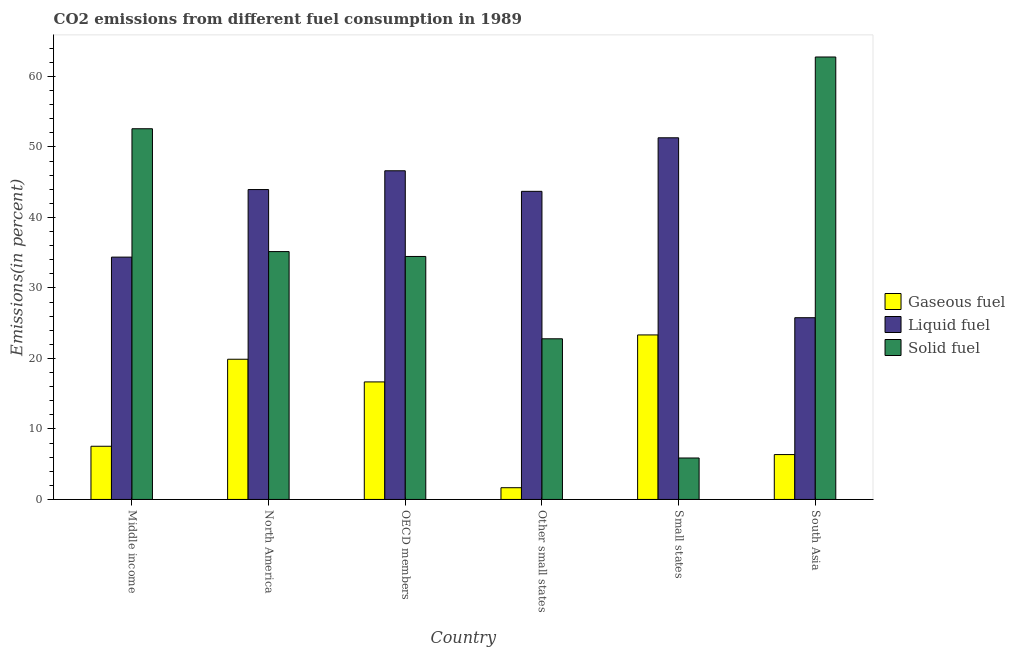How many groups of bars are there?
Your response must be concise. 6. How many bars are there on the 1st tick from the left?
Offer a very short reply. 3. How many bars are there on the 4th tick from the right?
Your answer should be compact. 3. What is the label of the 5th group of bars from the left?
Your answer should be very brief. Small states. What is the percentage of liquid fuel emission in Small states?
Your response must be concise. 51.3. Across all countries, what is the maximum percentage of gaseous fuel emission?
Make the answer very short. 23.34. Across all countries, what is the minimum percentage of liquid fuel emission?
Offer a terse response. 25.78. In which country was the percentage of liquid fuel emission maximum?
Provide a succinct answer. Small states. In which country was the percentage of gaseous fuel emission minimum?
Provide a succinct answer. Other small states. What is the total percentage of liquid fuel emission in the graph?
Keep it short and to the point. 245.73. What is the difference between the percentage of solid fuel emission in OECD members and that in Small states?
Make the answer very short. 28.59. What is the difference between the percentage of solid fuel emission in OECD members and the percentage of gaseous fuel emission in Middle income?
Give a very brief answer. 26.92. What is the average percentage of gaseous fuel emission per country?
Provide a succinct answer. 12.58. What is the difference between the percentage of liquid fuel emission and percentage of gaseous fuel emission in Other small states?
Provide a short and direct response. 42.04. What is the ratio of the percentage of solid fuel emission in OECD members to that in Other small states?
Give a very brief answer. 1.51. Is the difference between the percentage of liquid fuel emission in North America and Other small states greater than the difference between the percentage of solid fuel emission in North America and Other small states?
Give a very brief answer. No. What is the difference between the highest and the second highest percentage of solid fuel emission?
Ensure brevity in your answer.  10.18. What is the difference between the highest and the lowest percentage of solid fuel emission?
Ensure brevity in your answer.  56.88. In how many countries, is the percentage of solid fuel emission greater than the average percentage of solid fuel emission taken over all countries?
Give a very brief answer. 2. What does the 3rd bar from the left in Small states represents?
Ensure brevity in your answer.  Solid fuel. What does the 3rd bar from the right in North America represents?
Your response must be concise. Gaseous fuel. Is it the case that in every country, the sum of the percentage of gaseous fuel emission and percentage of liquid fuel emission is greater than the percentage of solid fuel emission?
Keep it short and to the point. No. How many bars are there?
Offer a very short reply. 18. Are all the bars in the graph horizontal?
Keep it short and to the point. No. Does the graph contain grids?
Keep it short and to the point. No. How are the legend labels stacked?
Make the answer very short. Vertical. What is the title of the graph?
Give a very brief answer. CO2 emissions from different fuel consumption in 1989. Does "Resident buildings and public services" appear as one of the legend labels in the graph?
Offer a terse response. No. What is the label or title of the Y-axis?
Your response must be concise. Emissions(in percent). What is the Emissions(in percent) in Gaseous fuel in Middle income?
Give a very brief answer. 7.55. What is the Emissions(in percent) of Liquid fuel in Middle income?
Offer a very short reply. 34.37. What is the Emissions(in percent) in Solid fuel in Middle income?
Provide a succinct answer. 52.58. What is the Emissions(in percent) of Gaseous fuel in North America?
Your answer should be very brief. 19.89. What is the Emissions(in percent) in Liquid fuel in North America?
Keep it short and to the point. 43.96. What is the Emissions(in percent) in Solid fuel in North America?
Make the answer very short. 35.16. What is the Emissions(in percent) of Gaseous fuel in OECD members?
Offer a terse response. 16.67. What is the Emissions(in percent) of Liquid fuel in OECD members?
Keep it short and to the point. 46.62. What is the Emissions(in percent) in Solid fuel in OECD members?
Ensure brevity in your answer.  34.47. What is the Emissions(in percent) in Gaseous fuel in Other small states?
Ensure brevity in your answer.  1.66. What is the Emissions(in percent) of Liquid fuel in Other small states?
Provide a succinct answer. 43.7. What is the Emissions(in percent) of Solid fuel in Other small states?
Ensure brevity in your answer.  22.79. What is the Emissions(in percent) of Gaseous fuel in Small states?
Your answer should be very brief. 23.34. What is the Emissions(in percent) in Liquid fuel in Small states?
Your answer should be compact. 51.3. What is the Emissions(in percent) in Solid fuel in Small states?
Keep it short and to the point. 5.88. What is the Emissions(in percent) in Gaseous fuel in South Asia?
Offer a very short reply. 6.37. What is the Emissions(in percent) of Liquid fuel in South Asia?
Keep it short and to the point. 25.78. What is the Emissions(in percent) in Solid fuel in South Asia?
Offer a very short reply. 62.76. Across all countries, what is the maximum Emissions(in percent) in Gaseous fuel?
Offer a very short reply. 23.34. Across all countries, what is the maximum Emissions(in percent) of Liquid fuel?
Provide a succinct answer. 51.3. Across all countries, what is the maximum Emissions(in percent) in Solid fuel?
Make the answer very short. 62.76. Across all countries, what is the minimum Emissions(in percent) of Gaseous fuel?
Your answer should be very brief. 1.66. Across all countries, what is the minimum Emissions(in percent) of Liquid fuel?
Your answer should be very brief. 25.78. Across all countries, what is the minimum Emissions(in percent) of Solid fuel?
Your answer should be very brief. 5.88. What is the total Emissions(in percent) of Gaseous fuel in the graph?
Your response must be concise. 75.47. What is the total Emissions(in percent) of Liquid fuel in the graph?
Make the answer very short. 245.73. What is the total Emissions(in percent) in Solid fuel in the graph?
Give a very brief answer. 213.63. What is the difference between the Emissions(in percent) of Gaseous fuel in Middle income and that in North America?
Offer a terse response. -12.34. What is the difference between the Emissions(in percent) in Liquid fuel in Middle income and that in North America?
Provide a short and direct response. -9.58. What is the difference between the Emissions(in percent) of Solid fuel in Middle income and that in North America?
Give a very brief answer. 17.43. What is the difference between the Emissions(in percent) of Gaseous fuel in Middle income and that in OECD members?
Provide a succinct answer. -9.13. What is the difference between the Emissions(in percent) of Liquid fuel in Middle income and that in OECD members?
Keep it short and to the point. -12.25. What is the difference between the Emissions(in percent) of Solid fuel in Middle income and that in OECD members?
Offer a terse response. 18.12. What is the difference between the Emissions(in percent) of Gaseous fuel in Middle income and that in Other small states?
Your answer should be compact. 5.88. What is the difference between the Emissions(in percent) of Liquid fuel in Middle income and that in Other small states?
Give a very brief answer. -9.33. What is the difference between the Emissions(in percent) in Solid fuel in Middle income and that in Other small states?
Offer a very short reply. 29.79. What is the difference between the Emissions(in percent) of Gaseous fuel in Middle income and that in Small states?
Your response must be concise. -15.79. What is the difference between the Emissions(in percent) in Liquid fuel in Middle income and that in Small states?
Offer a terse response. -16.93. What is the difference between the Emissions(in percent) in Solid fuel in Middle income and that in Small states?
Give a very brief answer. 46.7. What is the difference between the Emissions(in percent) in Gaseous fuel in Middle income and that in South Asia?
Your answer should be compact. 1.18. What is the difference between the Emissions(in percent) of Liquid fuel in Middle income and that in South Asia?
Your response must be concise. 8.59. What is the difference between the Emissions(in percent) of Solid fuel in Middle income and that in South Asia?
Your answer should be compact. -10.18. What is the difference between the Emissions(in percent) in Gaseous fuel in North America and that in OECD members?
Give a very brief answer. 3.22. What is the difference between the Emissions(in percent) of Liquid fuel in North America and that in OECD members?
Provide a short and direct response. -2.66. What is the difference between the Emissions(in percent) of Solid fuel in North America and that in OECD members?
Your answer should be compact. 0.69. What is the difference between the Emissions(in percent) of Gaseous fuel in North America and that in Other small states?
Offer a very short reply. 18.22. What is the difference between the Emissions(in percent) of Liquid fuel in North America and that in Other small states?
Provide a succinct answer. 0.25. What is the difference between the Emissions(in percent) in Solid fuel in North America and that in Other small states?
Your answer should be very brief. 12.37. What is the difference between the Emissions(in percent) in Gaseous fuel in North America and that in Small states?
Your response must be concise. -3.45. What is the difference between the Emissions(in percent) in Liquid fuel in North America and that in Small states?
Provide a succinct answer. -7.34. What is the difference between the Emissions(in percent) of Solid fuel in North America and that in Small states?
Your answer should be very brief. 29.28. What is the difference between the Emissions(in percent) in Gaseous fuel in North America and that in South Asia?
Keep it short and to the point. 13.52. What is the difference between the Emissions(in percent) in Liquid fuel in North America and that in South Asia?
Keep it short and to the point. 18.18. What is the difference between the Emissions(in percent) in Solid fuel in North America and that in South Asia?
Offer a terse response. -27.6. What is the difference between the Emissions(in percent) in Gaseous fuel in OECD members and that in Other small states?
Your answer should be compact. 15.01. What is the difference between the Emissions(in percent) of Liquid fuel in OECD members and that in Other small states?
Provide a succinct answer. 2.92. What is the difference between the Emissions(in percent) in Solid fuel in OECD members and that in Other small states?
Your answer should be compact. 11.68. What is the difference between the Emissions(in percent) in Gaseous fuel in OECD members and that in Small states?
Give a very brief answer. -6.66. What is the difference between the Emissions(in percent) of Liquid fuel in OECD members and that in Small states?
Your answer should be very brief. -4.68. What is the difference between the Emissions(in percent) in Solid fuel in OECD members and that in Small states?
Provide a succinct answer. 28.59. What is the difference between the Emissions(in percent) of Gaseous fuel in OECD members and that in South Asia?
Keep it short and to the point. 10.31. What is the difference between the Emissions(in percent) in Liquid fuel in OECD members and that in South Asia?
Keep it short and to the point. 20.84. What is the difference between the Emissions(in percent) in Solid fuel in OECD members and that in South Asia?
Keep it short and to the point. -28.29. What is the difference between the Emissions(in percent) in Gaseous fuel in Other small states and that in Small states?
Your answer should be very brief. -21.67. What is the difference between the Emissions(in percent) of Liquid fuel in Other small states and that in Small states?
Offer a terse response. -7.59. What is the difference between the Emissions(in percent) of Solid fuel in Other small states and that in Small states?
Provide a succinct answer. 16.91. What is the difference between the Emissions(in percent) of Gaseous fuel in Other small states and that in South Asia?
Make the answer very short. -4.7. What is the difference between the Emissions(in percent) of Liquid fuel in Other small states and that in South Asia?
Offer a terse response. 17.93. What is the difference between the Emissions(in percent) in Solid fuel in Other small states and that in South Asia?
Keep it short and to the point. -39.97. What is the difference between the Emissions(in percent) in Gaseous fuel in Small states and that in South Asia?
Provide a succinct answer. 16.97. What is the difference between the Emissions(in percent) in Liquid fuel in Small states and that in South Asia?
Provide a succinct answer. 25.52. What is the difference between the Emissions(in percent) of Solid fuel in Small states and that in South Asia?
Provide a short and direct response. -56.88. What is the difference between the Emissions(in percent) of Gaseous fuel in Middle income and the Emissions(in percent) of Liquid fuel in North America?
Your response must be concise. -36.41. What is the difference between the Emissions(in percent) of Gaseous fuel in Middle income and the Emissions(in percent) of Solid fuel in North America?
Your answer should be very brief. -27.61. What is the difference between the Emissions(in percent) of Liquid fuel in Middle income and the Emissions(in percent) of Solid fuel in North America?
Give a very brief answer. -0.78. What is the difference between the Emissions(in percent) of Gaseous fuel in Middle income and the Emissions(in percent) of Liquid fuel in OECD members?
Make the answer very short. -39.08. What is the difference between the Emissions(in percent) of Gaseous fuel in Middle income and the Emissions(in percent) of Solid fuel in OECD members?
Your answer should be very brief. -26.92. What is the difference between the Emissions(in percent) in Liquid fuel in Middle income and the Emissions(in percent) in Solid fuel in OECD members?
Provide a short and direct response. -0.09. What is the difference between the Emissions(in percent) of Gaseous fuel in Middle income and the Emissions(in percent) of Liquid fuel in Other small states?
Make the answer very short. -36.16. What is the difference between the Emissions(in percent) of Gaseous fuel in Middle income and the Emissions(in percent) of Solid fuel in Other small states?
Give a very brief answer. -15.24. What is the difference between the Emissions(in percent) in Liquid fuel in Middle income and the Emissions(in percent) in Solid fuel in Other small states?
Your answer should be very brief. 11.58. What is the difference between the Emissions(in percent) in Gaseous fuel in Middle income and the Emissions(in percent) in Liquid fuel in Small states?
Your response must be concise. -43.75. What is the difference between the Emissions(in percent) in Gaseous fuel in Middle income and the Emissions(in percent) in Solid fuel in Small states?
Your answer should be very brief. 1.66. What is the difference between the Emissions(in percent) in Liquid fuel in Middle income and the Emissions(in percent) in Solid fuel in Small states?
Ensure brevity in your answer.  28.49. What is the difference between the Emissions(in percent) in Gaseous fuel in Middle income and the Emissions(in percent) in Liquid fuel in South Asia?
Provide a succinct answer. -18.23. What is the difference between the Emissions(in percent) of Gaseous fuel in Middle income and the Emissions(in percent) of Solid fuel in South Asia?
Keep it short and to the point. -55.21. What is the difference between the Emissions(in percent) of Liquid fuel in Middle income and the Emissions(in percent) of Solid fuel in South Asia?
Your response must be concise. -28.39. What is the difference between the Emissions(in percent) in Gaseous fuel in North America and the Emissions(in percent) in Liquid fuel in OECD members?
Offer a very short reply. -26.73. What is the difference between the Emissions(in percent) in Gaseous fuel in North America and the Emissions(in percent) in Solid fuel in OECD members?
Offer a terse response. -14.58. What is the difference between the Emissions(in percent) of Liquid fuel in North America and the Emissions(in percent) of Solid fuel in OECD members?
Provide a short and direct response. 9.49. What is the difference between the Emissions(in percent) in Gaseous fuel in North America and the Emissions(in percent) in Liquid fuel in Other small states?
Ensure brevity in your answer.  -23.82. What is the difference between the Emissions(in percent) in Gaseous fuel in North America and the Emissions(in percent) in Solid fuel in Other small states?
Your response must be concise. -2.9. What is the difference between the Emissions(in percent) in Liquid fuel in North America and the Emissions(in percent) in Solid fuel in Other small states?
Give a very brief answer. 21.17. What is the difference between the Emissions(in percent) in Gaseous fuel in North America and the Emissions(in percent) in Liquid fuel in Small states?
Offer a terse response. -31.41. What is the difference between the Emissions(in percent) of Gaseous fuel in North America and the Emissions(in percent) of Solid fuel in Small states?
Provide a short and direct response. 14.01. What is the difference between the Emissions(in percent) of Liquid fuel in North America and the Emissions(in percent) of Solid fuel in Small states?
Give a very brief answer. 38.08. What is the difference between the Emissions(in percent) in Gaseous fuel in North America and the Emissions(in percent) in Liquid fuel in South Asia?
Ensure brevity in your answer.  -5.89. What is the difference between the Emissions(in percent) in Gaseous fuel in North America and the Emissions(in percent) in Solid fuel in South Asia?
Your answer should be very brief. -42.87. What is the difference between the Emissions(in percent) of Liquid fuel in North America and the Emissions(in percent) of Solid fuel in South Asia?
Provide a succinct answer. -18.8. What is the difference between the Emissions(in percent) in Gaseous fuel in OECD members and the Emissions(in percent) in Liquid fuel in Other small states?
Your response must be concise. -27.03. What is the difference between the Emissions(in percent) of Gaseous fuel in OECD members and the Emissions(in percent) of Solid fuel in Other small states?
Your answer should be very brief. -6.12. What is the difference between the Emissions(in percent) of Liquid fuel in OECD members and the Emissions(in percent) of Solid fuel in Other small states?
Your response must be concise. 23.83. What is the difference between the Emissions(in percent) in Gaseous fuel in OECD members and the Emissions(in percent) in Liquid fuel in Small states?
Provide a succinct answer. -34.63. What is the difference between the Emissions(in percent) of Gaseous fuel in OECD members and the Emissions(in percent) of Solid fuel in Small states?
Provide a short and direct response. 10.79. What is the difference between the Emissions(in percent) of Liquid fuel in OECD members and the Emissions(in percent) of Solid fuel in Small states?
Offer a very short reply. 40.74. What is the difference between the Emissions(in percent) of Gaseous fuel in OECD members and the Emissions(in percent) of Liquid fuel in South Asia?
Make the answer very short. -9.11. What is the difference between the Emissions(in percent) of Gaseous fuel in OECD members and the Emissions(in percent) of Solid fuel in South Asia?
Your response must be concise. -46.09. What is the difference between the Emissions(in percent) in Liquid fuel in OECD members and the Emissions(in percent) in Solid fuel in South Asia?
Make the answer very short. -16.14. What is the difference between the Emissions(in percent) of Gaseous fuel in Other small states and the Emissions(in percent) of Liquid fuel in Small states?
Keep it short and to the point. -49.63. What is the difference between the Emissions(in percent) of Gaseous fuel in Other small states and the Emissions(in percent) of Solid fuel in Small states?
Provide a succinct answer. -4.22. What is the difference between the Emissions(in percent) of Liquid fuel in Other small states and the Emissions(in percent) of Solid fuel in Small states?
Your answer should be compact. 37.82. What is the difference between the Emissions(in percent) of Gaseous fuel in Other small states and the Emissions(in percent) of Liquid fuel in South Asia?
Make the answer very short. -24.11. What is the difference between the Emissions(in percent) in Gaseous fuel in Other small states and the Emissions(in percent) in Solid fuel in South Asia?
Your response must be concise. -61.09. What is the difference between the Emissions(in percent) of Liquid fuel in Other small states and the Emissions(in percent) of Solid fuel in South Asia?
Your response must be concise. -19.05. What is the difference between the Emissions(in percent) in Gaseous fuel in Small states and the Emissions(in percent) in Liquid fuel in South Asia?
Provide a succinct answer. -2.44. What is the difference between the Emissions(in percent) in Gaseous fuel in Small states and the Emissions(in percent) in Solid fuel in South Asia?
Your answer should be very brief. -39.42. What is the difference between the Emissions(in percent) in Liquid fuel in Small states and the Emissions(in percent) in Solid fuel in South Asia?
Offer a terse response. -11.46. What is the average Emissions(in percent) of Gaseous fuel per country?
Provide a succinct answer. 12.58. What is the average Emissions(in percent) in Liquid fuel per country?
Your answer should be very brief. 40.96. What is the average Emissions(in percent) of Solid fuel per country?
Your response must be concise. 35.61. What is the difference between the Emissions(in percent) in Gaseous fuel and Emissions(in percent) in Liquid fuel in Middle income?
Your response must be concise. -26.83. What is the difference between the Emissions(in percent) in Gaseous fuel and Emissions(in percent) in Solid fuel in Middle income?
Offer a terse response. -45.04. What is the difference between the Emissions(in percent) in Liquid fuel and Emissions(in percent) in Solid fuel in Middle income?
Offer a very short reply. -18.21. What is the difference between the Emissions(in percent) of Gaseous fuel and Emissions(in percent) of Liquid fuel in North America?
Your answer should be compact. -24.07. What is the difference between the Emissions(in percent) in Gaseous fuel and Emissions(in percent) in Solid fuel in North America?
Provide a succinct answer. -15.27. What is the difference between the Emissions(in percent) in Liquid fuel and Emissions(in percent) in Solid fuel in North America?
Your response must be concise. 8.8. What is the difference between the Emissions(in percent) in Gaseous fuel and Emissions(in percent) in Liquid fuel in OECD members?
Make the answer very short. -29.95. What is the difference between the Emissions(in percent) in Gaseous fuel and Emissions(in percent) in Solid fuel in OECD members?
Your answer should be compact. -17.79. What is the difference between the Emissions(in percent) in Liquid fuel and Emissions(in percent) in Solid fuel in OECD members?
Your answer should be very brief. 12.15. What is the difference between the Emissions(in percent) of Gaseous fuel and Emissions(in percent) of Liquid fuel in Other small states?
Provide a short and direct response. -42.04. What is the difference between the Emissions(in percent) of Gaseous fuel and Emissions(in percent) of Solid fuel in Other small states?
Offer a terse response. -21.12. What is the difference between the Emissions(in percent) in Liquid fuel and Emissions(in percent) in Solid fuel in Other small states?
Keep it short and to the point. 20.92. What is the difference between the Emissions(in percent) in Gaseous fuel and Emissions(in percent) in Liquid fuel in Small states?
Your response must be concise. -27.96. What is the difference between the Emissions(in percent) in Gaseous fuel and Emissions(in percent) in Solid fuel in Small states?
Your answer should be compact. 17.46. What is the difference between the Emissions(in percent) of Liquid fuel and Emissions(in percent) of Solid fuel in Small states?
Give a very brief answer. 45.42. What is the difference between the Emissions(in percent) of Gaseous fuel and Emissions(in percent) of Liquid fuel in South Asia?
Make the answer very short. -19.41. What is the difference between the Emissions(in percent) in Gaseous fuel and Emissions(in percent) in Solid fuel in South Asia?
Offer a very short reply. -56.39. What is the difference between the Emissions(in percent) in Liquid fuel and Emissions(in percent) in Solid fuel in South Asia?
Keep it short and to the point. -36.98. What is the ratio of the Emissions(in percent) in Gaseous fuel in Middle income to that in North America?
Your response must be concise. 0.38. What is the ratio of the Emissions(in percent) of Liquid fuel in Middle income to that in North America?
Give a very brief answer. 0.78. What is the ratio of the Emissions(in percent) of Solid fuel in Middle income to that in North America?
Your answer should be very brief. 1.5. What is the ratio of the Emissions(in percent) in Gaseous fuel in Middle income to that in OECD members?
Keep it short and to the point. 0.45. What is the ratio of the Emissions(in percent) of Liquid fuel in Middle income to that in OECD members?
Give a very brief answer. 0.74. What is the ratio of the Emissions(in percent) of Solid fuel in Middle income to that in OECD members?
Keep it short and to the point. 1.53. What is the ratio of the Emissions(in percent) of Gaseous fuel in Middle income to that in Other small states?
Give a very brief answer. 4.53. What is the ratio of the Emissions(in percent) of Liquid fuel in Middle income to that in Other small states?
Your answer should be very brief. 0.79. What is the ratio of the Emissions(in percent) of Solid fuel in Middle income to that in Other small states?
Provide a succinct answer. 2.31. What is the ratio of the Emissions(in percent) in Gaseous fuel in Middle income to that in Small states?
Your answer should be compact. 0.32. What is the ratio of the Emissions(in percent) in Liquid fuel in Middle income to that in Small states?
Provide a succinct answer. 0.67. What is the ratio of the Emissions(in percent) of Solid fuel in Middle income to that in Small states?
Keep it short and to the point. 8.94. What is the ratio of the Emissions(in percent) of Gaseous fuel in Middle income to that in South Asia?
Make the answer very short. 1.19. What is the ratio of the Emissions(in percent) in Liquid fuel in Middle income to that in South Asia?
Give a very brief answer. 1.33. What is the ratio of the Emissions(in percent) in Solid fuel in Middle income to that in South Asia?
Offer a very short reply. 0.84. What is the ratio of the Emissions(in percent) in Gaseous fuel in North America to that in OECD members?
Make the answer very short. 1.19. What is the ratio of the Emissions(in percent) in Liquid fuel in North America to that in OECD members?
Provide a succinct answer. 0.94. What is the ratio of the Emissions(in percent) in Solid fuel in North America to that in OECD members?
Provide a succinct answer. 1.02. What is the ratio of the Emissions(in percent) of Gaseous fuel in North America to that in Other small states?
Your response must be concise. 11.94. What is the ratio of the Emissions(in percent) in Solid fuel in North America to that in Other small states?
Provide a succinct answer. 1.54. What is the ratio of the Emissions(in percent) of Gaseous fuel in North America to that in Small states?
Your answer should be very brief. 0.85. What is the ratio of the Emissions(in percent) in Liquid fuel in North America to that in Small states?
Your response must be concise. 0.86. What is the ratio of the Emissions(in percent) in Solid fuel in North America to that in Small states?
Offer a very short reply. 5.98. What is the ratio of the Emissions(in percent) of Gaseous fuel in North America to that in South Asia?
Provide a succinct answer. 3.12. What is the ratio of the Emissions(in percent) in Liquid fuel in North America to that in South Asia?
Offer a terse response. 1.71. What is the ratio of the Emissions(in percent) in Solid fuel in North America to that in South Asia?
Ensure brevity in your answer.  0.56. What is the ratio of the Emissions(in percent) in Gaseous fuel in OECD members to that in Other small states?
Provide a short and direct response. 10.01. What is the ratio of the Emissions(in percent) of Liquid fuel in OECD members to that in Other small states?
Provide a succinct answer. 1.07. What is the ratio of the Emissions(in percent) in Solid fuel in OECD members to that in Other small states?
Provide a short and direct response. 1.51. What is the ratio of the Emissions(in percent) of Gaseous fuel in OECD members to that in Small states?
Your answer should be compact. 0.71. What is the ratio of the Emissions(in percent) in Liquid fuel in OECD members to that in Small states?
Provide a short and direct response. 0.91. What is the ratio of the Emissions(in percent) in Solid fuel in OECD members to that in Small states?
Provide a short and direct response. 5.86. What is the ratio of the Emissions(in percent) of Gaseous fuel in OECD members to that in South Asia?
Provide a short and direct response. 2.62. What is the ratio of the Emissions(in percent) of Liquid fuel in OECD members to that in South Asia?
Offer a very short reply. 1.81. What is the ratio of the Emissions(in percent) in Solid fuel in OECD members to that in South Asia?
Provide a short and direct response. 0.55. What is the ratio of the Emissions(in percent) in Gaseous fuel in Other small states to that in Small states?
Keep it short and to the point. 0.07. What is the ratio of the Emissions(in percent) in Liquid fuel in Other small states to that in Small states?
Keep it short and to the point. 0.85. What is the ratio of the Emissions(in percent) in Solid fuel in Other small states to that in Small states?
Your response must be concise. 3.88. What is the ratio of the Emissions(in percent) of Gaseous fuel in Other small states to that in South Asia?
Provide a succinct answer. 0.26. What is the ratio of the Emissions(in percent) of Liquid fuel in Other small states to that in South Asia?
Provide a short and direct response. 1.7. What is the ratio of the Emissions(in percent) of Solid fuel in Other small states to that in South Asia?
Provide a short and direct response. 0.36. What is the ratio of the Emissions(in percent) in Gaseous fuel in Small states to that in South Asia?
Keep it short and to the point. 3.67. What is the ratio of the Emissions(in percent) of Liquid fuel in Small states to that in South Asia?
Keep it short and to the point. 1.99. What is the ratio of the Emissions(in percent) in Solid fuel in Small states to that in South Asia?
Offer a terse response. 0.09. What is the difference between the highest and the second highest Emissions(in percent) of Gaseous fuel?
Your answer should be compact. 3.45. What is the difference between the highest and the second highest Emissions(in percent) of Liquid fuel?
Your response must be concise. 4.68. What is the difference between the highest and the second highest Emissions(in percent) of Solid fuel?
Your response must be concise. 10.18. What is the difference between the highest and the lowest Emissions(in percent) of Gaseous fuel?
Your answer should be compact. 21.67. What is the difference between the highest and the lowest Emissions(in percent) in Liquid fuel?
Give a very brief answer. 25.52. What is the difference between the highest and the lowest Emissions(in percent) in Solid fuel?
Your answer should be compact. 56.88. 